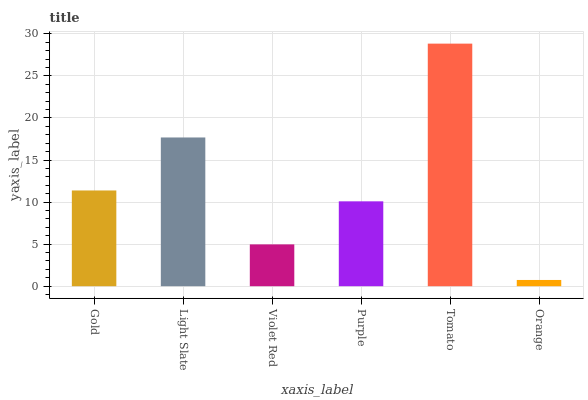Is Light Slate the minimum?
Answer yes or no. No. Is Light Slate the maximum?
Answer yes or no. No. Is Light Slate greater than Gold?
Answer yes or no. Yes. Is Gold less than Light Slate?
Answer yes or no. Yes. Is Gold greater than Light Slate?
Answer yes or no. No. Is Light Slate less than Gold?
Answer yes or no. No. Is Gold the high median?
Answer yes or no. Yes. Is Purple the low median?
Answer yes or no. Yes. Is Violet Red the high median?
Answer yes or no. No. Is Violet Red the low median?
Answer yes or no. No. 